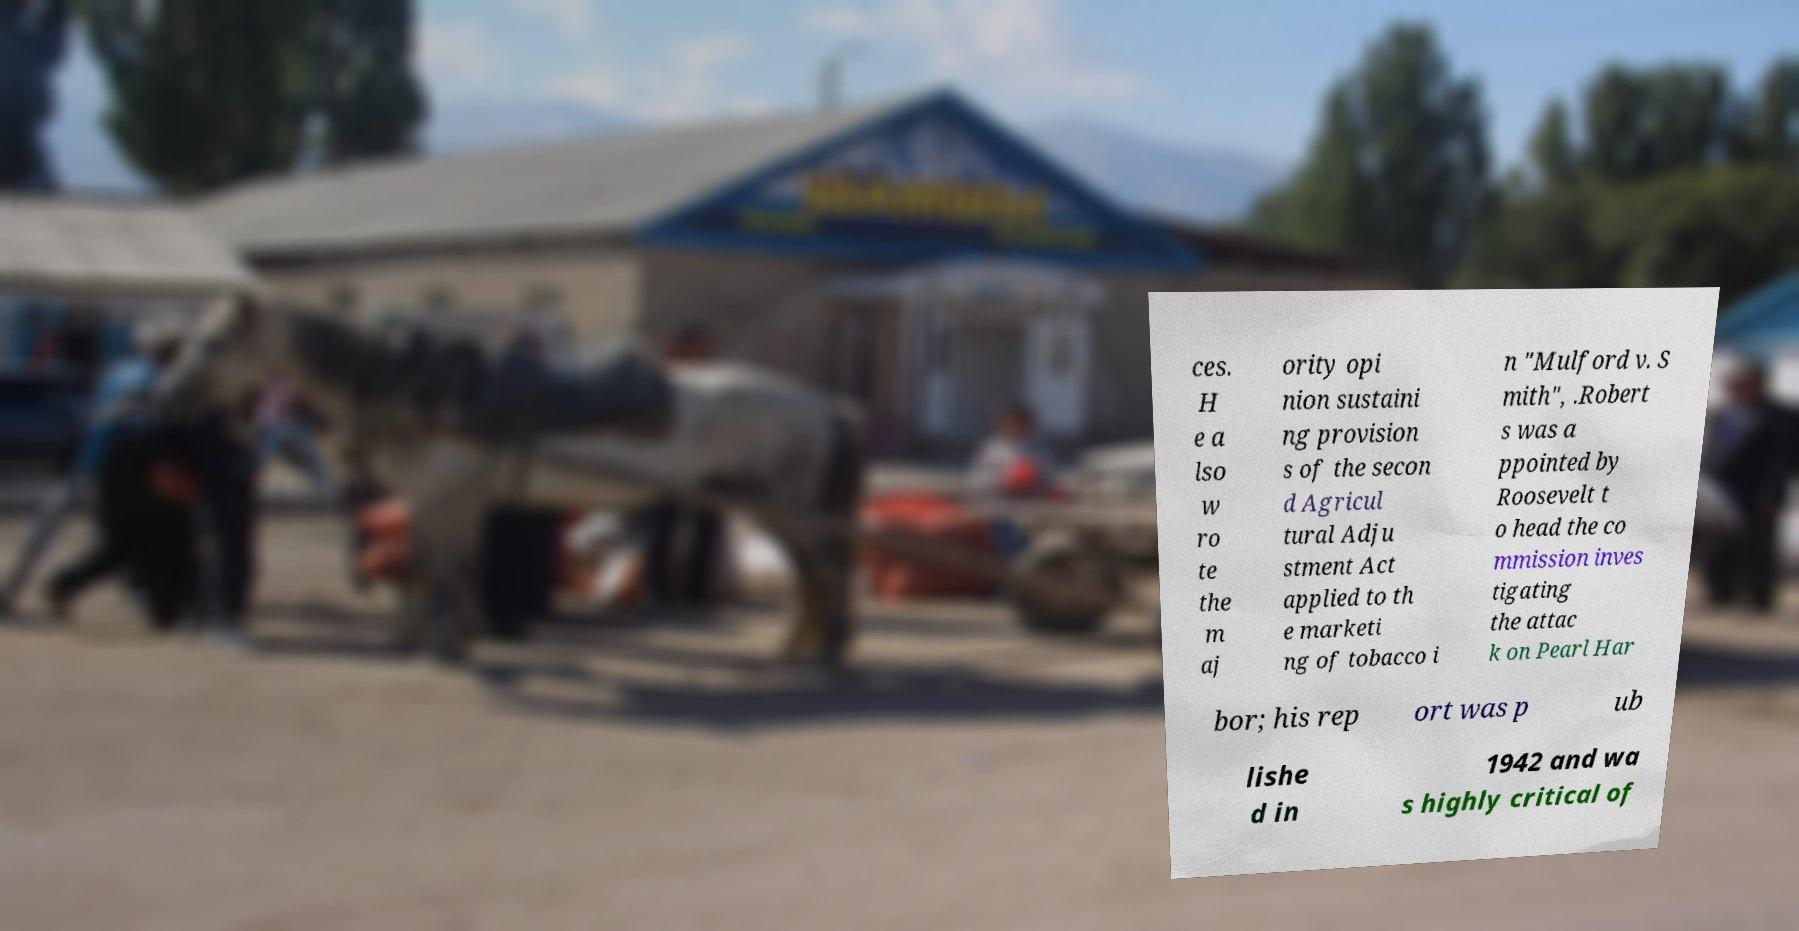Please identify and transcribe the text found in this image. ces. H e a lso w ro te the m aj ority opi nion sustaini ng provision s of the secon d Agricul tural Adju stment Act applied to th e marketi ng of tobacco i n "Mulford v. S mith", .Robert s was a ppointed by Roosevelt t o head the co mmission inves tigating the attac k on Pearl Har bor; his rep ort was p ub lishe d in 1942 and wa s highly critical of 